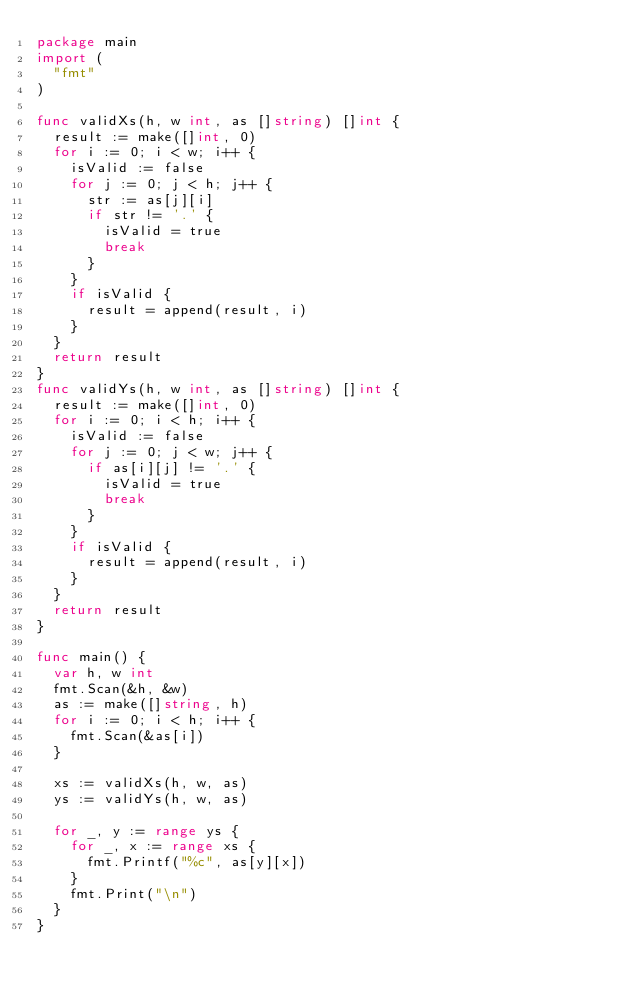<code> <loc_0><loc_0><loc_500><loc_500><_Go_>package main
import (
  "fmt"
)

func validXs(h, w int, as []string) []int {
  result := make([]int, 0)
  for i := 0; i < w; i++ {
    isValid := false
    for j := 0; j < h; j++ {
      str := as[j][i]
      if str != '.' {
        isValid = true
        break
      }
    }
    if isValid {
      result = append(result, i)
    }
  }
  return result
}
func validYs(h, w int, as []string) []int {
  result := make([]int, 0)
  for i := 0; i < h; i++ {
    isValid := false
    for j := 0; j < w; j++ {
      if as[i][j] != '.' {
        isValid = true
        break
      }
    }
    if isValid {
      result = append(result, i)
    }
  }
  return result
}

func main() {
  var h, w int
  fmt.Scan(&h, &w)
  as := make([]string, h)
  for i := 0; i < h; i++ {
    fmt.Scan(&as[i])
  }
  
  xs := validXs(h, w, as)
  ys := validYs(h, w, as)

  for _, y := range ys {
    for _, x := range xs {
      fmt.Printf("%c", as[y][x])
    }
    fmt.Print("\n")
  }
}</code> 